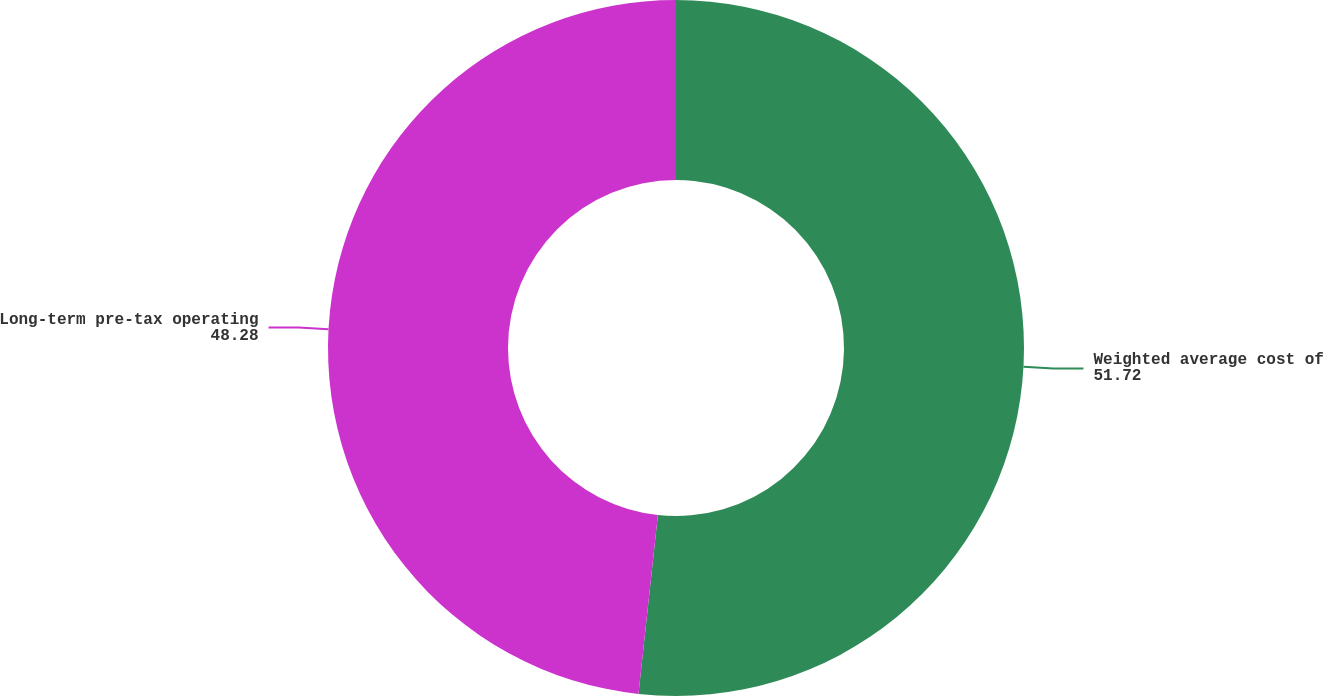<chart> <loc_0><loc_0><loc_500><loc_500><pie_chart><fcel>Weighted average cost of<fcel>Long-term pre-tax operating<nl><fcel>51.72%<fcel>48.28%<nl></chart> 